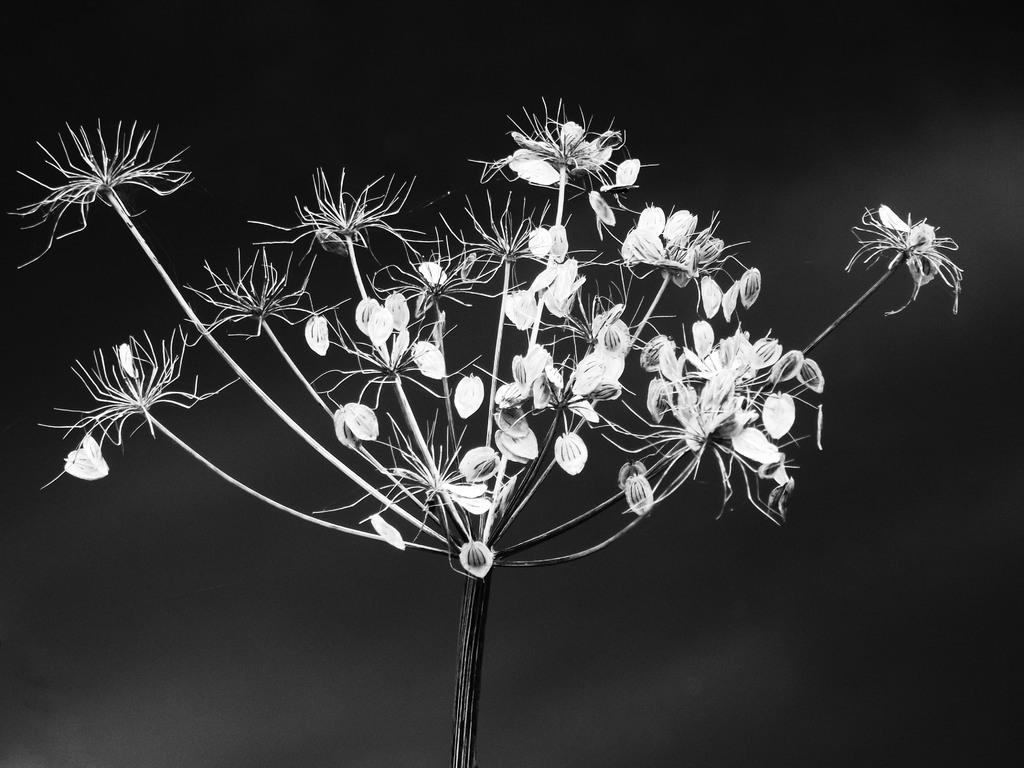What type of plant is in the picture? There is an artificial plant in the picture. Can you describe the artificial plant's appearance? The artificial plant has spine flowers and petals. What type of image is this? The image is a photograph. What is the name of the dinosaur that is eating the artificial plant in the image? There are no dinosaurs present in the image, and the artificial plant is not being eaten by any creature. 